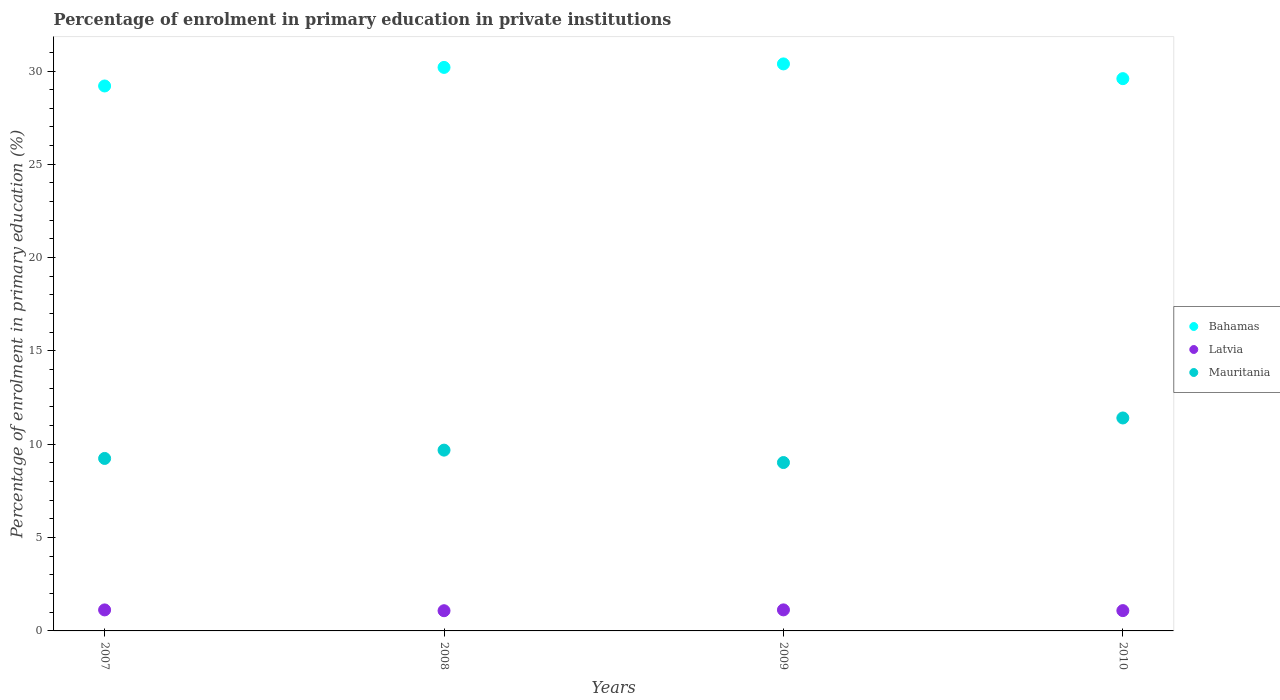How many different coloured dotlines are there?
Provide a succinct answer. 3. What is the percentage of enrolment in primary education in Latvia in 2008?
Give a very brief answer. 1.08. Across all years, what is the maximum percentage of enrolment in primary education in Mauritania?
Make the answer very short. 11.41. Across all years, what is the minimum percentage of enrolment in primary education in Latvia?
Give a very brief answer. 1.08. In which year was the percentage of enrolment in primary education in Mauritania maximum?
Give a very brief answer. 2010. What is the total percentage of enrolment in primary education in Mauritania in the graph?
Provide a succinct answer. 39.36. What is the difference between the percentage of enrolment in primary education in Mauritania in 2009 and that in 2010?
Your answer should be very brief. -2.39. What is the difference between the percentage of enrolment in primary education in Bahamas in 2010 and the percentage of enrolment in primary education in Latvia in 2007?
Your answer should be compact. 28.46. What is the average percentage of enrolment in primary education in Latvia per year?
Give a very brief answer. 1.11. In the year 2009, what is the difference between the percentage of enrolment in primary education in Mauritania and percentage of enrolment in primary education in Latvia?
Your response must be concise. 7.89. What is the ratio of the percentage of enrolment in primary education in Latvia in 2008 to that in 2009?
Your answer should be very brief. 0.96. What is the difference between the highest and the second highest percentage of enrolment in primary education in Mauritania?
Offer a very short reply. 1.72. What is the difference between the highest and the lowest percentage of enrolment in primary education in Mauritania?
Provide a short and direct response. 2.39. Is the sum of the percentage of enrolment in primary education in Latvia in 2007 and 2008 greater than the maximum percentage of enrolment in primary education in Mauritania across all years?
Provide a short and direct response. No. Is it the case that in every year, the sum of the percentage of enrolment in primary education in Mauritania and percentage of enrolment in primary education in Latvia  is greater than the percentage of enrolment in primary education in Bahamas?
Give a very brief answer. No. How many years are there in the graph?
Provide a succinct answer. 4. What is the difference between two consecutive major ticks on the Y-axis?
Ensure brevity in your answer.  5. Does the graph contain grids?
Keep it short and to the point. No. Where does the legend appear in the graph?
Offer a terse response. Center right. What is the title of the graph?
Provide a short and direct response. Percentage of enrolment in primary education in private institutions. Does "Moldova" appear as one of the legend labels in the graph?
Give a very brief answer. No. What is the label or title of the Y-axis?
Offer a terse response. Percentage of enrolment in primary education (%). What is the Percentage of enrolment in primary education (%) of Bahamas in 2007?
Offer a very short reply. 29.2. What is the Percentage of enrolment in primary education (%) in Latvia in 2007?
Provide a short and direct response. 1.13. What is the Percentage of enrolment in primary education (%) of Mauritania in 2007?
Offer a very short reply. 9.24. What is the Percentage of enrolment in primary education (%) of Bahamas in 2008?
Provide a succinct answer. 30.19. What is the Percentage of enrolment in primary education (%) in Latvia in 2008?
Offer a very short reply. 1.08. What is the Percentage of enrolment in primary education (%) in Mauritania in 2008?
Your response must be concise. 9.69. What is the Percentage of enrolment in primary education (%) of Bahamas in 2009?
Offer a terse response. 30.38. What is the Percentage of enrolment in primary education (%) of Latvia in 2009?
Make the answer very short. 1.13. What is the Percentage of enrolment in primary education (%) of Mauritania in 2009?
Offer a terse response. 9.02. What is the Percentage of enrolment in primary education (%) in Bahamas in 2010?
Offer a terse response. 29.59. What is the Percentage of enrolment in primary education (%) of Latvia in 2010?
Give a very brief answer. 1.09. What is the Percentage of enrolment in primary education (%) in Mauritania in 2010?
Give a very brief answer. 11.41. Across all years, what is the maximum Percentage of enrolment in primary education (%) in Bahamas?
Keep it short and to the point. 30.38. Across all years, what is the maximum Percentage of enrolment in primary education (%) of Latvia?
Offer a very short reply. 1.13. Across all years, what is the maximum Percentage of enrolment in primary education (%) in Mauritania?
Keep it short and to the point. 11.41. Across all years, what is the minimum Percentage of enrolment in primary education (%) in Bahamas?
Provide a short and direct response. 29.2. Across all years, what is the minimum Percentage of enrolment in primary education (%) of Latvia?
Your answer should be very brief. 1.08. Across all years, what is the minimum Percentage of enrolment in primary education (%) in Mauritania?
Your answer should be very brief. 9.02. What is the total Percentage of enrolment in primary education (%) in Bahamas in the graph?
Offer a terse response. 119.36. What is the total Percentage of enrolment in primary education (%) of Latvia in the graph?
Make the answer very short. 4.42. What is the total Percentage of enrolment in primary education (%) of Mauritania in the graph?
Make the answer very short. 39.36. What is the difference between the Percentage of enrolment in primary education (%) in Bahamas in 2007 and that in 2008?
Ensure brevity in your answer.  -0.99. What is the difference between the Percentage of enrolment in primary education (%) in Latvia in 2007 and that in 2008?
Keep it short and to the point. 0.04. What is the difference between the Percentage of enrolment in primary education (%) in Mauritania in 2007 and that in 2008?
Ensure brevity in your answer.  -0.45. What is the difference between the Percentage of enrolment in primary education (%) in Bahamas in 2007 and that in 2009?
Ensure brevity in your answer.  -1.18. What is the difference between the Percentage of enrolment in primary education (%) of Latvia in 2007 and that in 2009?
Your answer should be very brief. -0. What is the difference between the Percentage of enrolment in primary education (%) in Mauritania in 2007 and that in 2009?
Offer a very short reply. 0.22. What is the difference between the Percentage of enrolment in primary education (%) of Bahamas in 2007 and that in 2010?
Make the answer very short. -0.39. What is the difference between the Percentage of enrolment in primary education (%) in Latvia in 2007 and that in 2010?
Ensure brevity in your answer.  0.04. What is the difference between the Percentage of enrolment in primary education (%) in Mauritania in 2007 and that in 2010?
Your response must be concise. -2.17. What is the difference between the Percentage of enrolment in primary education (%) in Bahamas in 2008 and that in 2009?
Provide a succinct answer. -0.19. What is the difference between the Percentage of enrolment in primary education (%) in Latvia in 2008 and that in 2009?
Ensure brevity in your answer.  -0.04. What is the difference between the Percentage of enrolment in primary education (%) in Mauritania in 2008 and that in 2009?
Your answer should be very brief. 0.66. What is the difference between the Percentage of enrolment in primary education (%) of Bahamas in 2008 and that in 2010?
Offer a very short reply. 0.6. What is the difference between the Percentage of enrolment in primary education (%) of Latvia in 2008 and that in 2010?
Provide a succinct answer. -0.01. What is the difference between the Percentage of enrolment in primary education (%) in Mauritania in 2008 and that in 2010?
Your response must be concise. -1.72. What is the difference between the Percentage of enrolment in primary education (%) of Bahamas in 2009 and that in 2010?
Offer a terse response. 0.79. What is the difference between the Percentage of enrolment in primary education (%) in Latvia in 2009 and that in 2010?
Provide a short and direct response. 0.04. What is the difference between the Percentage of enrolment in primary education (%) of Mauritania in 2009 and that in 2010?
Offer a terse response. -2.39. What is the difference between the Percentage of enrolment in primary education (%) in Bahamas in 2007 and the Percentage of enrolment in primary education (%) in Latvia in 2008?
Your answer should be compact. 28.12. What is the difference between the Percentage of enrolment in primary education (%) of Bahamas in 2007 and the Percentage of enrolment in primary education (%) of Mauritania in 2008?
Provide a succinct answer. 19.51. What is the difference between the Percentage of enrolment in primary education (%) in Latvia in 2007 and the Percentage of enrolment in primary education (%) in Mauritania in 2008?
Offer a very short reply. -8.56. What is the difference between the Percentage of enrolment in primary education (%) of Bahamas in 2007 and the Percentage of enrolment in primary education (%) of Latvia in 2009?
Provide a succinct answer. 28.07. What is the difference between the Percentage of enrolment in primary education (%) of Bahamas in 2007 and the Percentage of enrolment in primary education (%) of Mauritania in 2009?
Provide a short and direct response. 20.18. What is the difference between the Percentage of enrolment in primary education (%) in Latvia in 2007 and the Percentage of enrolment in primary education (%) in Mauritania in 2009?
Provide a short and direct response. -7.9. What is the difference between the Percentage of enrolment in primary education (%) in Bahamas in 2007 and the Percentage of enrolment in primary education (%) in Latvia in 2010?
Offer a terse response. 28.11. What is the difference between the Percentage of enrolment in primary education (%) of Bahamas in 2007 and the Percentage of enrolment in primary education (%) of Mauritania in 2010?
Keep it short and to the point. 17.79. What is the difference between the Percentage of enrolment in primary education (%) in Latvia in 2007 and the Percentage of enrolment in primary education (%) in Mauritania in 2010?
Provide a succinct answer. -10.28. What is the difference between the Percentage of enrolment in primary education (%) in Bahamas in 2008 and the Percentage of enrolment in primary education (%) in Latvia in 2009?
Offer a terse response. 29.07. What is the difference between the Percentage of enrolment in primary education (%) in Bahamas in 2008 and the Percentage of enrolment in primary education (%) in Mauritania in 2009?
Offer a terse response. 21.17. What is the difference between the Percentage of enrolment in primary education (%) of Latvia in 2008 and the Percentage of enrolment in primary education (%) of Mauritania in 2009?
Ensure brevity in your answer.  -7.94. What is the difference between the Percentage of enrolment in primary education (%) in Bahamas in 2008 and the Percentage of enrolment in primary education (%) in Latvia in 2010?
Ensure brevity in your answer.  29.11. What is the difference between the Percentage of enrolment in primary education (%) of Bahamas in 2008 and the Percentage of enrolment in primary education (%) of Mauritania in 2010?
Keep it short and to the point. 18.78. What is the difference between the Percentage of enrolment in primary education (%) of Latvia in 2008 and the Percentage of enrolment in primary education (%) of Mauritania in 2010?
Offer a terse response. -10.33. What is the difference between the Percentage of enrolment in primary education (%) in Bahamas in 2009 and the Percentage of enrolment in primary education (%) in Latvia in 2010?
Keep it short and to the point. 29.29. What is the difference between the Percentage of enrolment in primary education (%) of Bahamas in 2009 and the Percentage of enrolment in primary education (%) of Mauritania in 2010?
Your answer should be very brief. 18.97. What is the difference between the Percentage of enrolment in primary education (%) of Latvia in 2009 and the Percentage of enrolment in primary education (%) of Mauritania in 2010?
Your answer should be compact. -10.28. What is the average Percentage of enrolment in primary education (%) of Bahamas per year?
Your answer should be compact. 29.84. What is the average Percentage of enrolment in primary education (%) of Latvia per year?
Your answer should be compact. 1.11. What is the average Percentage of enrolment in primary education (%) of Mauritania per year?
Provide a short and direct response. 9.84. In the year 2007, what is the difference between the Percentage of enrolment in primary education (%) in Bahamas and Percentage of enrolment in primary education (%) in Latvia?
Ensure brevity in your answer.  28.07. In the year 2007, what is the difference between the Percentage of enrolment in primary education (%) of Bahamas and Percentage of enrolment in primary education (%) of Mauritania?
Offer a very short reply. 19.96. In the year 2007, what is the difference between the Percentage of enrolment in primary education (%) in Latvia and Percentage of enrolment in primary education (%) in Mauritania?
Ensure brevity in your answer.  -8.12. In the year 2008, what is the difference between the Percentage of enrolment in primary education (%) in Bahamas and Percentage of enrolment in primary education (%) in Latvia?
Your response must be concise. 29.11. In the year 2008, what is the difference between the Percentage of enrolment in primary education (%) in Bahamas and Percentage of enrolment in primary education (%) in Mauritania?
Provide a succinct answer. 20.51. In the year 2008, what is the difference between the Percentage of enrolment in primary education (%) in Latvia and Percentage of enrolment in primary education (%) in Mauritania?
Your answer should be compact. -8.6. In the year 2009, what is the difference between the Percentage of enrolment in primary education (%) of Bahamas and Percentage of enrolment in primary education (%) of Latvia?
Offer a very short reply. 29.25. In the year 2009, what is the difference between the Percentage of enrolment in primary education (%) in Bahamas and Percentage of enrolment in primary education (%) in Mauritania?
Ensure brevity in your answer.  21.36. In the year 2009, what is the difference between the Percentage of enrolment in primary education (%) in Latvia and Percentage of enrolment in primary education (%) in Mauritania?
Give a very brief answer. -7.89. In the year 2010, what is the difference between the Percentage of enrolment in primary education (%) of Bahamas and Percentage of enrolment in primary education (%) of Latvia?
Make the answer very short. 28.5. In the year 2010, what is the difference between the Percentage of enrolment in primary education (%) of Bahamas and Percentage of enrolment in primary education (%) of Mauritania?
Give a very brief answer. 18.18. In the year 2010, what is the difference between the Percentage of enrolment in primary education (%) in Latvia and Percentage of enrolment in primary education (%) in Mauritania?
Provide a succinct answer. -10.32. What is the ratio of the Percentage of enrolment in primary education (%) of Bahamas in 2007 to that in 2008?
Your answer should be compact. 0.97. What is the ratio of the Percentage of enrolment in primary education (%) in Latvia in 2007 to that in 2008?
Your answer should be very brief. 1.04. What is the ratio of the Percentage of enrolment in primary education (%) of Mauritania in 2007 to that in 2008?
Offer a terse response. 0.95. What is the ratio of the Percentage of enrolment in primary education (%) in Bahamas in 2007 to that in 2009?
Keep it short and to the point. 0.96. What is the ratio of the Percentage of enrolment in primary education (%) in Latvia in 2007 to that in 2009?
Give a very brief answer. 1. What is the ratio of the Percentage of enrolment in primary education (%) in Mauritania in 2007 to that in 2009?
Offer a very short reply. 1.02. What is the ratio of the Percentage of enrolment in primary education (%) in Bahamas in 2007 to that in 2010?
Your response must be concise. 0.99. What is the ratio of the Percentage of enrolment in primary education (%) in Latvia in 2007 to that in 2010?
Make the answer very short. 1.03. What is the ratio of the Percentage of enrolment in primary education (%) in Mauritania in 2007 to that in 2010?
Offer a terse response. 0.81. What is the ratio of the Percentage of enrolment in primary education (%) in Bahamas in 2008 to that in 2009?
Your answer should be compact. 0.99. What is the ratio of the Percentage of enrolment in primary education (%) of Latvia in 2008 to that in 2009?
Provide a short and direct response. 0.96. What is the ratio of the Percentage of enrolment in primary education (%) of Mauritania in 2008 to that in 2009?
Provide a succinct answer. 1.07. What is the ratio of the Percentage of enrolment in primary education (%) in Bahamas in 2008 to that in 2010?
Provide a succinct answer. 1.02. What is the ratio of the Percentage of enrolment in primary education (%) of Mauritania in 2008 to that in 2010?
Give a very brief answer. 0.85. What is the ratio of the Percentage of enrolment in primary education (%) in Bahamas in 2009 to that in 2010?
Offer a terse response. 1.03. What is the ratio of the Percentage of enrolment in primary education (%) of Latvia in 2009 to that in 2010?
Your answer should be very brief. 1.04. What is the ratio of the Percentage of enrolment in primary education (%) of Mauritania in 2009 to that in 2010?
Provide a succinct answer. 0.79. What is the difference between the highest and the second highest Percentage of enrolment in primary education (%) in Bahamas?
Keep it short and to the point. 0.19. What is the difference between the highest and the second highest Percentage of enrolment in primary education (%) of Latvia?
Provide a short and direct response. 0. What is the difference between the highest and the second highest Percentage of enrolment in primary education (%) in Mauritania?
Make the answer very short. 1.72. What is the difference between the highest and the lowest Percentage of enrolment in primary education (%) in Bahamas?
Keep it short and to the point. 1.18. What is the difference between the highest and the lowest Percentage of enrolment in primary education (%) in Latvia?
Your response must be concise. 0.04. What is the difference between the highest and the lowest Percentage of enrolment in primary education (%) in Mauritania?
Keep it short and to the point. 2.39. 